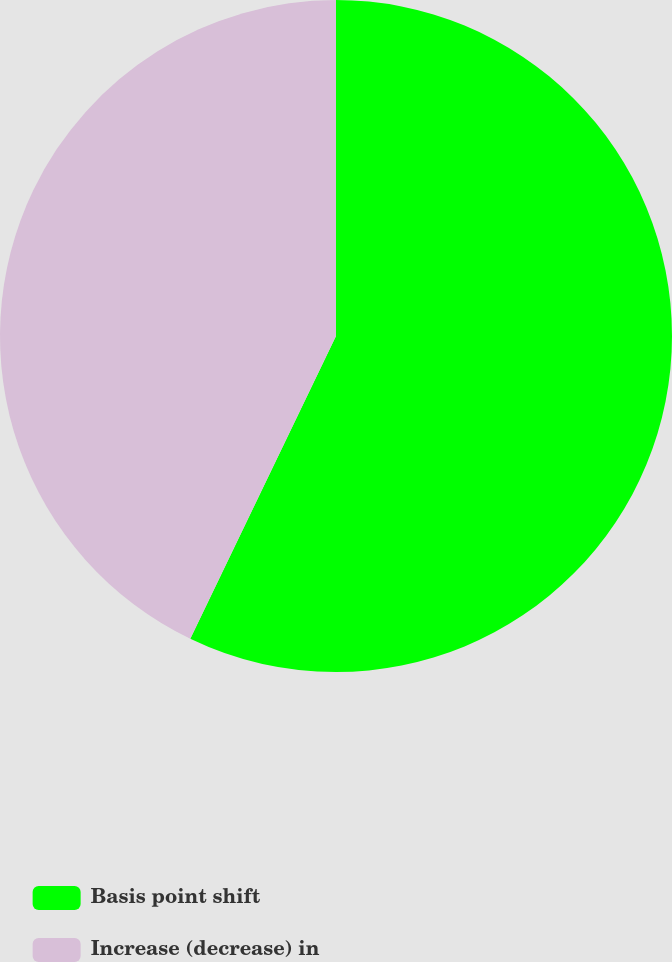<chart> <loc_0><loc_0><loc_500><loc_500><pie_chart><fcel>Basis point shift<fcel>Increase (decrease) in<nl><fcel>57.14%<fcel>42.86%<nl></chart> 